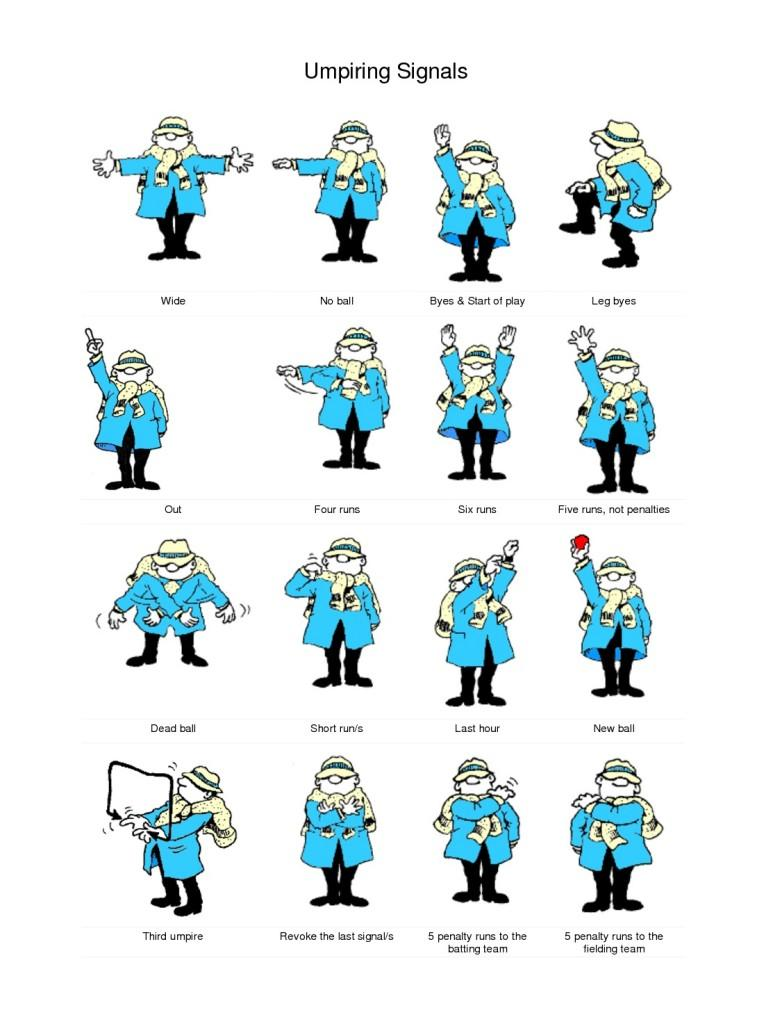Outline some significant characteristics in this image. The eighth signal mentioned in this infographic is 'Five runs, not penalties.' The seventh signal mentioned in the infographic is "six runs. The ninth signal mentioned in this infographic is 'dead ball,' which refers to the situation in football when the ball becomes unplayable due to a specific event or circumstance, such as a player being injured, a flag being thrown, or a ball going out of bounds. The sixth signal mentioned in the infographic is "Four runs. The eleventh signal mentioned in the infographic is "Last hour. 